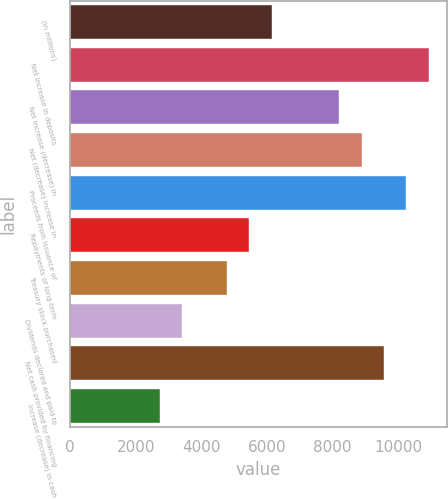Convert chart to OTSL. <chart><loc_0><loc_0><loc_500><loc_500><bar_chart><fcel>(in millions)<fcel>Net increase in deposits<fcel>Net increase (decrease) in<fcel>Net (decrease) increase in<fcel>Proceeds from issuance of<fcel>Repayments of long-term<fcel>Treasury stock purchased<fcel>Dividends declared and paid to<fcel>Net cash provided by financing<fcel>Increase (decrease) in cash<nl><fcel>6149.1<fcel>10929.4<fcel>8197.8<fcel>8880.7<fcel>10246.5<fcel>5466.2<fcel>4783.3<fcel>3417.5<fcel>9563.6<fcel>2734.6<nl></chart> 